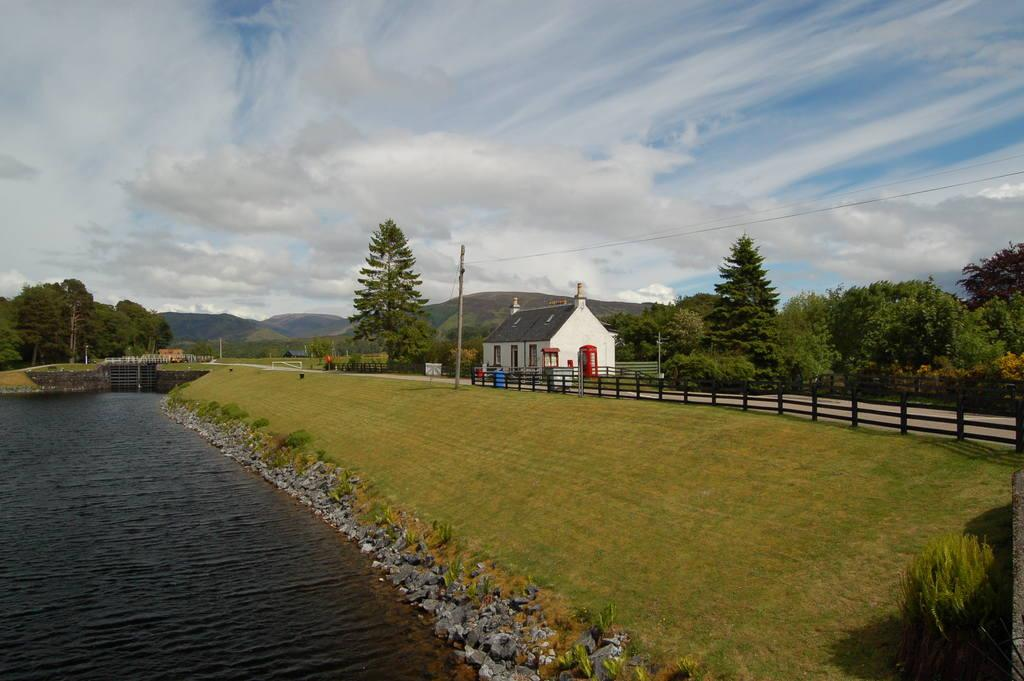What is one of the natural elements present in the image? There is water in the image. What type of terrain can be seen in the image? There are stones, grass, and hills in the image. What type of structure is visible in the image? There is a house in the image. What infrastructure elements are present in the image? Current poles and wires are visible in the image. What type of vegetation can be seen in the image? There are trees in the image. What is the condition of the sky in the background? The sky in the background is cloudy. What letters are visible on the key in the image? There is no key present in the image, so there are no letters to be seen. How does the earthquake affect the water in the image? There is no earthquake present in the image, so its effects on the water cannot be determined. 